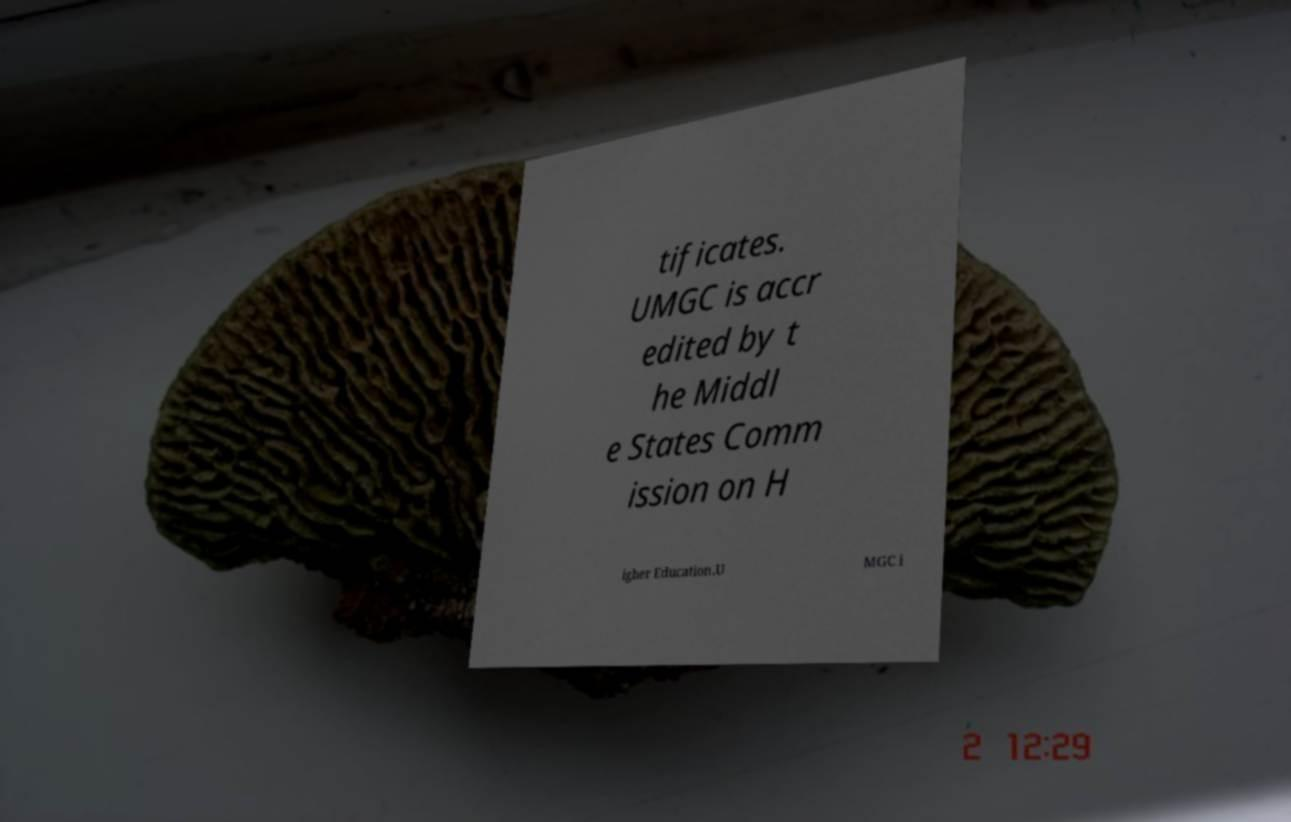Could you assist in decoding the text presented in this image and type it out clearly? tificates. UMGC is accr edited by t he Middl e States Comm ission on H igher Education.U MGC i 